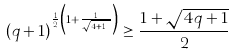Convert formula to latex. <formula><loc_0><loc_0><loc_500><loc_500>( q + 1 ) ^ { \frac { 1 } { 2 } \left ( 1 + \frac { 1 } { \sqrt { 4 q + 1 } } \right ) } \geq \frac { 1 + \sqrt { 4 q + 1 } } { 2 }</formula> 